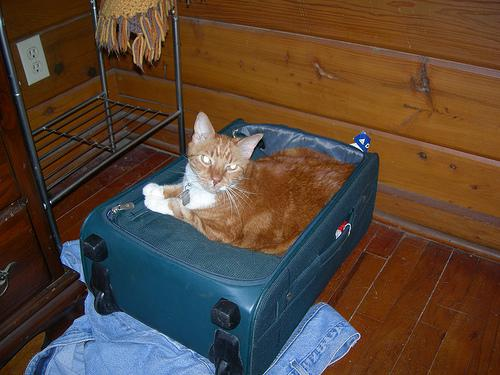Question: what is on the suitcase?
Choices:
A. Dog.
B. Cat.
C. Mouse.
D. Dora.
Answer with the letter. Answer: B Question: what color is the cat?
Choices:
A. Brown.
B. Black.
C. Orange.
D. Grey.
Answer with the letter. Answer: C Question: what is on the wall?
Choices:
A. A painting.
B. A mirror.
C. Electric outlet.
D. Candles.
Answer with the letter. Answer: C Question: what is the cat doing?
Choices:
A. Laying down.
B. Sleeping.
C. Chasing a string.
D. Sitting.
Answer with the letter. Answer: A Question: what is underneath the suitcase?
Choices:
A. Another suitcase.
B. A rug.
C. Clothes.
D. A bag.
Answer with the letter. Answer: C 